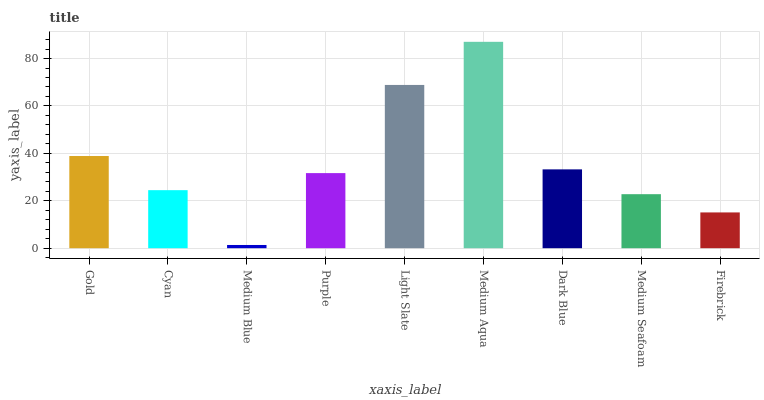Is Medium Blue the minimum?
Answer yes or no. Yes. Is Medium Aqua the maximum?
Answer yes or no. Yes. Is Cyan the minimum?
Answer yes or no. No. Is Cyan the maximum?
Answer yes or no. No. Is Gold greater than Cyan?
Answer yes or no. Yes. Is Cyan less than Gold?
Answer yes or no. Yes. Is Cyan greater than Gold?
Answer yes or no. No. Is Gold less than Cyan?
Answer yes or no. No. Is Purple the high median?
Answer yes or no. Yes. Is Purple the low median?
Answer yes or no. Yes. Is Light Slate the high median?
Answer yes or no. No. Is Gold the low median?
Answer yes or no. No. 